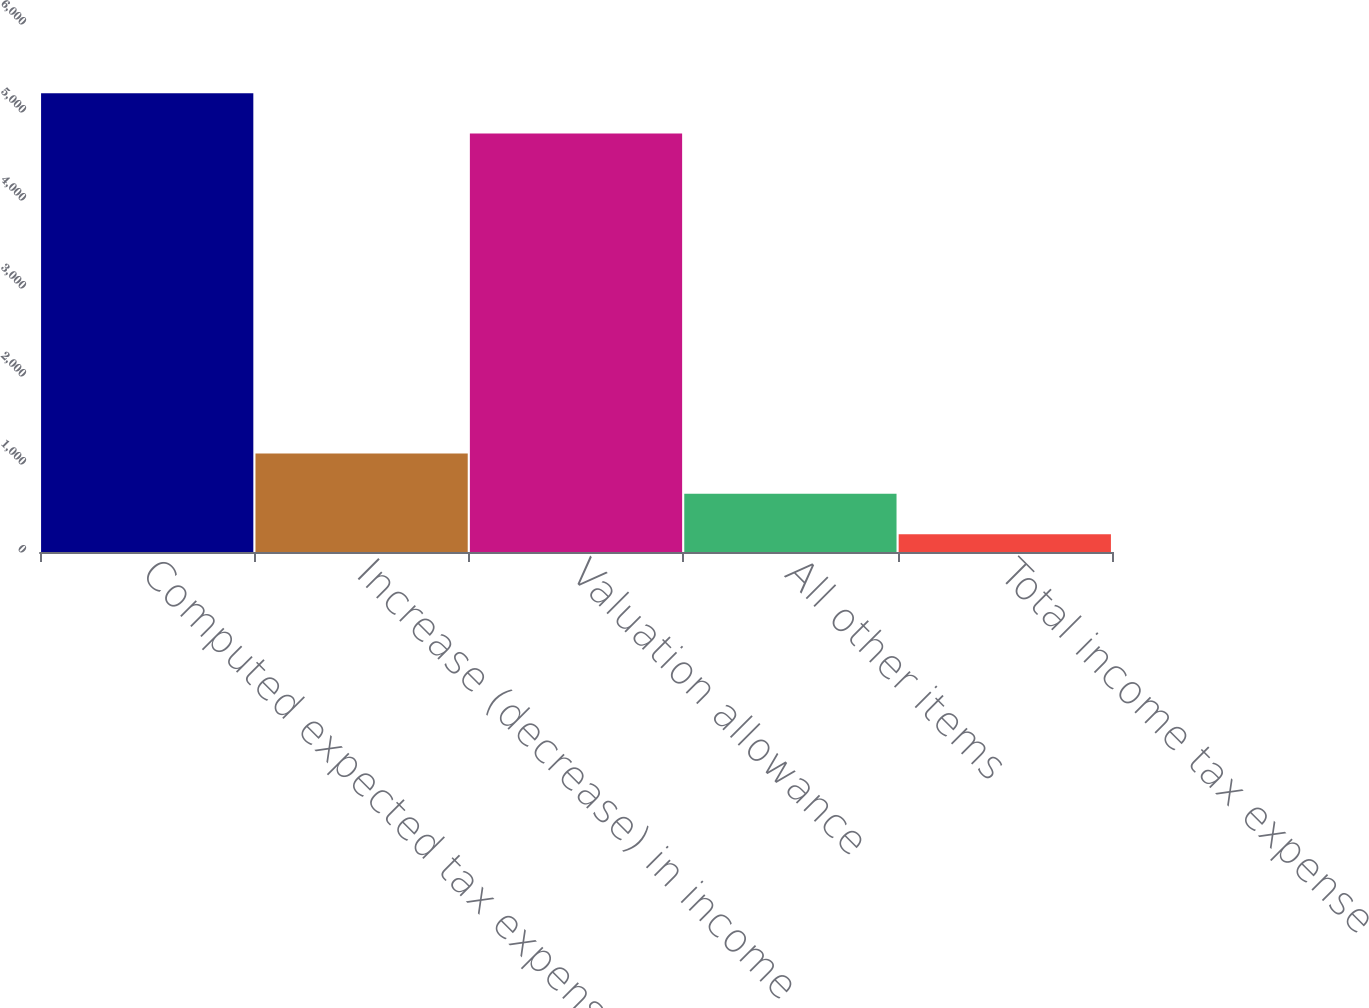Convert chart. <chart><loc_0><loc_0><loc_500><loc_500><bar_chart><fcel>Computed expected tax expense<fcel>Increase (decrease) in income<fcel>Valuation allowance<fcel>All other items<fcel>Total income tax expense<nl><fcel>5213.9<fcel>1119.8<fcel>4755<fcel>660.9<fcel>202<nl></chart> 